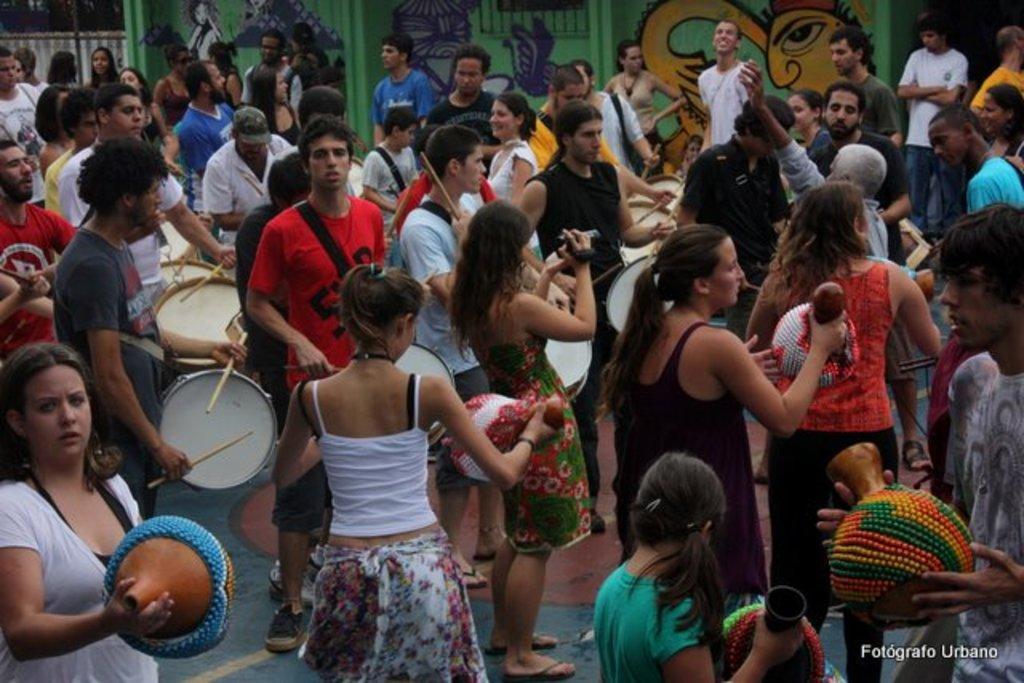Describe this image in one or two sentences. In this picture we can see a group of people where some are playing drums and some are holding cameras in their hands and taking pictures and they are standing and in the background we can see wall with painting. 